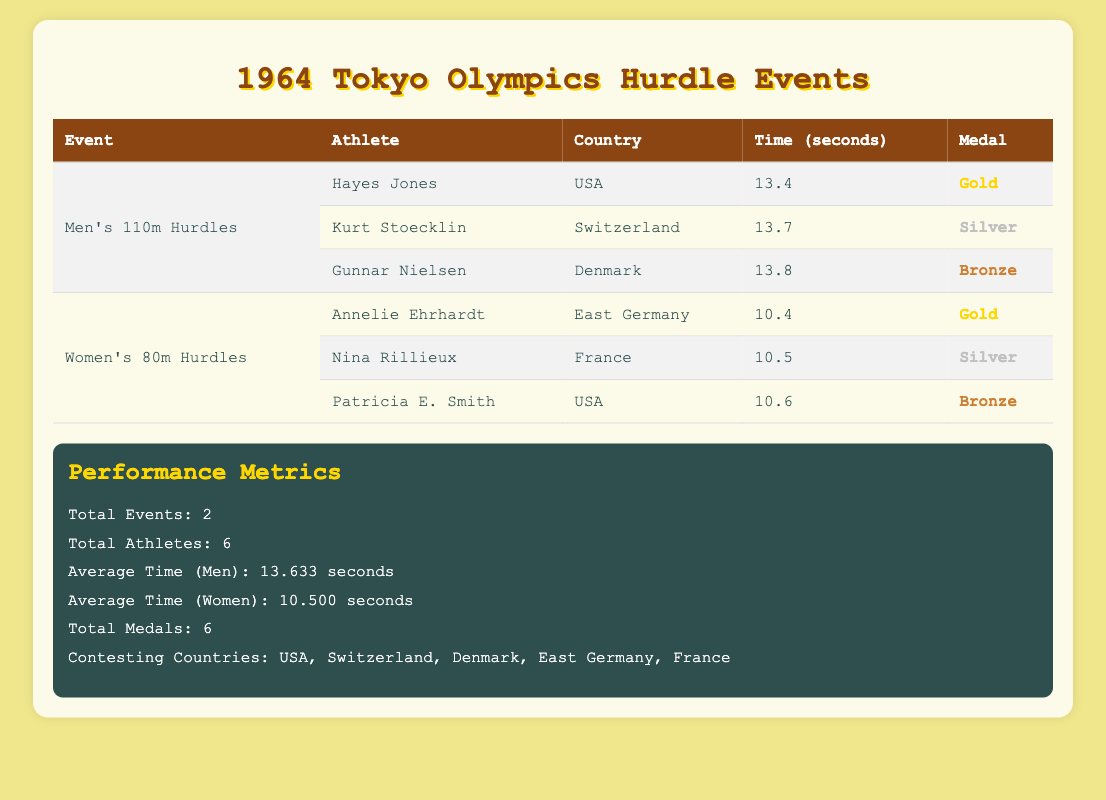What was the winning time for the Men's 110m Hurdles event? The winning time is noted next to the athlete who received the Gold medal, which is 13.4 seconds for Hayes Jones from the USA.
Answer: 13.4 seconds Which country won the Gold medal in the Women's 80m Hurdles? The athlete who won the Gold medal in this event is Annelie Ehrhardt, who represented East Germany.
Answer: East Germany How many total medals were awarded in the hurdle events? The table indicates that a total of 6 medals were awarded across the two hurdle events, with 3 for men and 3 for women.
Answer: 6 What is the average time for the women in their hurdle event? The average time for women is provided in the performance metrics section, which states the average time is 10.500 seconds.
Answer: 10.500 seconds Did any athlete from the USA win a medal in the Women's 80m Hurdles? Yes, the table shows that Patricia E. Smith from the USA won the Bronze medal in the Women's 80m Hurdles.
Answer: Yes What is the difference between the winning times of the Men's and Women's hurdle events? The winning time for men is 13.4 seconds and for women, it is 10.4 seconds. The difference is 13.4 - 10.4 = 3.0 seconds.
Answer: 3.0 seconds Which athlete had the slowest time in the Men's 110m Hurdles? To find the slowest time, we compare the times of all three male athletes. Gunnar Nielsen had a time of 13.8 seconds, which is the highest among them.
Answer: Gunnar Nielsen Which countries participated in both hurdle events? By analyzing the countries listed under the athletes, the USA is the only country that competed in both events (Men's 110m and Women's 80m Hurdles).
Answer: USA What is the total number of athletes from countries that did not win any medals? The countries that did not win medals are Switzerland, Denmark, East Germany, and France. Counting their athletes: Switzerland (1), Denmark (1), East Germany (1), and France (1). Thus, the total is 4 athletes.
Answer: 4 